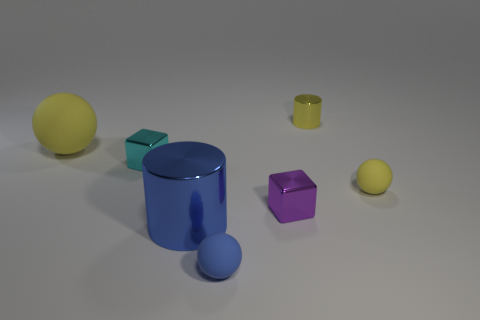What number of objects are both in front of the small cylinder and behind the cyan thing?
Provide a succinct answer. 1. Do the cyan shiny block and the yellow cylinder have the same size?
Your answer should be compact. Yes. There is a rubber object in front of the blue cylinder; is it the same size as the large metallic thing?
Keep it short and to the point. No. There is a block that is to the left of the large cylinder; what color is it?
Offer a terse response. Cyan. What number of small metallic cylinders are there?
Offer a very short reply. 1. The tiny cyan thing that is made of the same material as the tiny yellow cylinder is what shape?
Ensure brevity in your answer.  Cube. There is a tiny object behind the large rubber sphere; is it the same color as the matte object on the right side of the yellow metallic object?
Give a very brief answer. Yes. Are there the same number of blue spheres that are behind the small cyan object and tiny blue balls?
Offer a very short reply. No. What number of big blue things are in front of the cyan shiny object?
Provide a short and direct response. 1. How big is the blue ball?
Make the answer very short. Small. 